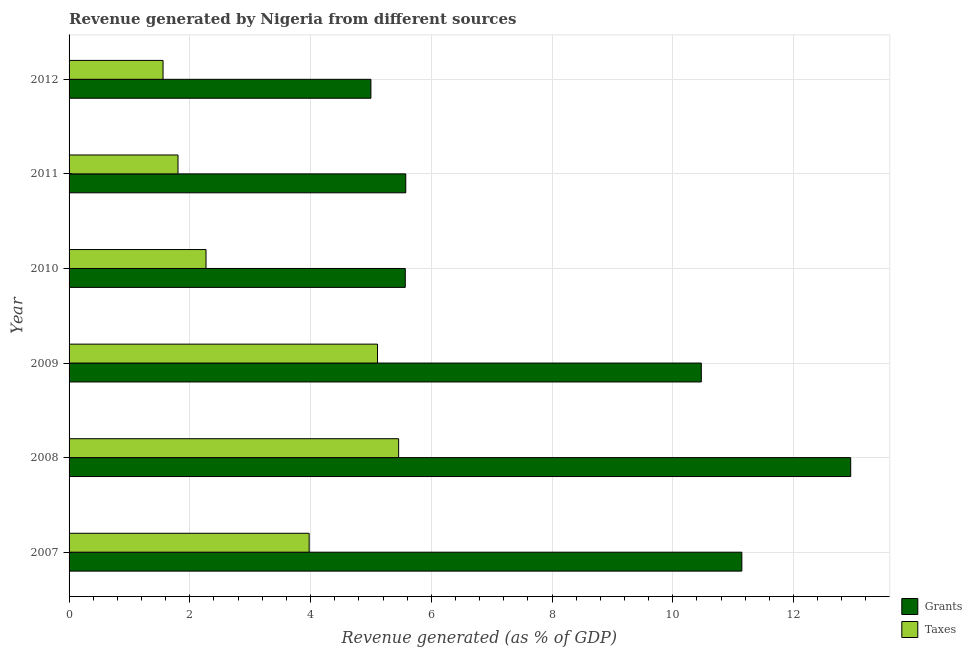How many different coloured bars are there?
Offer a very short reply. 2. Are the number of bars on each tick of the Y-axis equal?
Keep it short and to the point. Yes. How many bars are there on the 1st tick from the top?
Give a very brief answer. 2. In how many cases, is the number of bars for a given year not equal to the number of legend labels?
Provide a short and direct response. 0. What is the revenue generated by grants in 2011?
Offer a terse response. 5.58. Across all years, what is the maximum revenue generated by grants?
Provide a short and direct response. 12.95. Across all years, what is the minimum revenue generated by taxes?
Offer a terse response. 1.56. In which year was the revenue generated by taxes minimum?
Provide a short and direct response. 2012. What is the total revenue generated by grants in the graph?
Provide a short and direct response. 50.71. What is the difference between the revenue generated by grants in 2010 and that in 2011?
Give a very brief answer. -0.01. What is the difference between the revenue generated by grants in 2009 and the revenue generated by taxes in 2011?
Make the answer very short. 8.67. What is the average revenue generated by grants per year?
Keep it short and to the point. 8.45. In the year 2008, what is the difference between the revenue generated by grants and revenue generated by taxes?
Provide a short and direct response. 7.49. What is the ratio of the revenue generated by taxes in 2007 to that in 2011?
Ensure brevity in your answer.  2.2. Is the difference between the revenue generated by taxes in 2008 and 2010 greater than the difference between the revenue generated by grants in 2008 and 2010?
Offer a terse response. No. What is the difference between the highest and the second highest revenue generated by grants?
Your response must be concise. 1.8. What is the difference between the highest and the lowest revenue generated by taxes?
Ensure brevity in your answer.  3.9. In how many years, is the revenue generated by grants greater than the average revenue generated by grants taken over all years?
Give a very brief answer. 3. Is the sum of the revenue generated by taxes in 2007 and 2008 greater than the maximum revenue generated by grants across all years?
Your answer should be very brief. No. What does the 1st bar from the top in 2007 represents?
Your answer should be very brief. Taxes. What does the 2nd bar from the bottom in 2007 represents?
Make the answer very short. Taxes. How many bars are there?
Your response must be concise. 12. Are all the bars in the graph horizontal?
Give a very brief answer. Yes. How many years are there in the graph?
Ensure brevity in your answer.  6. Are the values on the major ticks of X-axis written in scientific E-notation?
Ensure brevity in your answer.  No. Does the graph contain any zero values?
Make the answer very short. No. Does the graph contain grids?
Keep it short and to the point. Yes. How are the legend labels stacked?
Provide a short and direct response. Vertical. What is the title of the graph?
Your answer should be very brief. Revenue generated by Nigeria from different sources. Does "Nitrous oxide" appear as one of the legend labels in the graph?
Offer a very short reply. No. What is the label or title of the X-axis?
Offer a terse response. Revenue generated (as % of GDP). What is the label or title of the Y-axis?
Your answer should be compact. Year. What is the Revenue generated (as % of GDP) of Grants in 2007?
Offer a terse response. 11.14. What is the Revenue generated (as % of GDP) of Taxes in 2007?
Offer a terse response. 3.98. What is the Revenue generated (as % of GDP) of Grants in 2008?
Give a very brief answer. 12.95. What is the Revenue generated (as % of GDP) of Taxes in 2008?
Your answer should be compact. 5.46. What is the Revenue generated (as % of GDP) in Grants in 2009?
Your response must be concise. 10.47. What is the Revenue generated (as % of GDP) of Taxes in 2009?
Ensure brevity in your answer.  5.11. What is the Revenue generated (as % of GDP) of Grants in 2010?
Offer a terse response. 5.57. What is the Revenue generated (as % of GDP) of Taxes in 2010?
Give a very brief answer. 2.27. What is the Revenue generated (as % of GDP) of Grants in 2011?
Your answer should be compact. 5.58. What is the Revenue generated (as % of GDP) in Taxes in 2011?
Offer a very short reply. 1.8. What is the Revenue generated (as % of GDP) in Grants in 2012?
Provide a short and direct response. 5. What is the Revenue generated (as % of GDP) of Taxes in 2012?
Offer a very short reply. 1.56. Across all years, what is the maximum Revenue generated (as % of GDP) of Grants?
Your response must be concise. 12.95. Across all years, what is the maximum Revenue generated (as % of GDP) of Taxes?
Your answer should be compact. 5.46. Across all years, what is the minimum Revenue generated (as % of GDP) in Grants?
Your answer should be compact. 5. Across all years, what is the minimum Revenue generated (as % of GDP) of Taxes?
Ensure brevity in your answer.  1.56. What is the total Revenue generated (as % of GDP) in Grants in the graph?
Ensure brevity in your answer.  50.71. What is the total Revenue generated (as % of GDP) in Taxes in the graph?
Make the answer very short. 20.17. What is the difference between the Revenue generated (as % of GDP) of Grants in 2007 and that in 2008?
Keep it short and to the point. -1.8. What is the difference between the Revenue generated (as % of GDP) of Taxes in 2007 and that in 2008?
Your answer should be very brief. -1.48. What is the difference between the Revenue generated (as % of GDP) of Grants in 2007 and that in 2009?
Offer a very short reply. 0.67. What is the difference between the Revenue generated (as % of GDP) of Taxes in 2007 and that in 2009?
Provide a short and direct response. -1.13. What is the difference between the Revenue generated (as % of GDP) of Grants in 2007 and that in 2010?
Keep it short and to the point. 5.58. What is the difference between the Revenue generated (as % of GDP) of Taxes in 2007 and that in 2010?
Your answer should be very brief. 1.71. What is the difference between the Revenue generated (as % of GDP) in Grants in 2007 and that in 2011?
Offer a very short reply. 5.57. What is the difference between the Revenue generated (as % of GDP) in Taxes in 2007 and that in 2011?
Make the answer very short. 2.17. What is the difference between the Revenue generated (as % of GDP) in Grants in 2007 and that in 2012?
Provide a succinct answer. 6.14. What is the difference between the Revenue generated (as % of GDP) of Taxes in 2007 and that in 2012?
Keep it short and to the point. 2.42. What is the difference between the Revenue generated (as % of GDP) in Grants in 2008 and that in 2009?
Ensure brevity in your answer.  2.47. What is the difference between the Revenue generated (as % of GDP) of Taxes in 2008 and that in 2009?
Keep it short and to the point. 0.35. What is the difference between the Revenue generated (as % of GDP) in Grants in 2008 and that in 2010?
Offer a very short reply. 7.38. What is the difference between the Revenue generated (as % of GDP) of Taxes in 2008 and that in 2010?
Your response must be concise. 3.19. What is the difference between the Revenue generated (as % of GDP) in Grants in 2008 and that in 2011?
Give a very brief answer. 7.37. What is the difference between the Revenue generated (as % of GDP) in Taxes in 2008 and that in 2011?
Keep it short and to the point. 3.65. What is the difference between the Revenue generated (as % of GDP) in Grants in 2008 and that in 2012?
Give a very brief answer. 7.95. What is the difference between the Revenue generated (as % of GDP) of Taxes in 2008 and that in 2012?
Provide a short and direct response. 3.9. What is the difference between the Revenue generated (as % of GDP) of Grants in 2009 and that in 2010?
Keep it short and to the point. 4.9. What is the difference between the Revenue generated (as % of GDP) in Taxes in 2009 and that in 2010?
Give a very brief answer. 2.84. What is the difference between the Revenue generated (as % of GDP) in Grants in 2009 and that in 2011?
Provide a succinct answer. 4.9. What is the difference between the Revenue generated (as % of GDP) in Taxes in 2009 and that in 2011?
Make the answer very short. 3.3. What is the difference between the Revenue generated (as % of GDP) of Grants in 2009 and that in 2012?
Offer a terse response. 5.47. What is the difference between the Revenue generated (as % of GDP) in Taxes in 2009 and that in 2012?
Keep it short and to the point. 3.55. What is the difference between the Revenue generated (as % of GDP) of Grants in 2010 and that in 2011?
Provide a succinct answer. -0.01. What is the difference between the Revenue generated (as % of GDP) in Taxes in 2010 and that in 2011?
Offer a terse response. 0.46. What is the difference between the Revenue generated (as % of GDP) of Grants in 2010 and that in 2012?
Ensure brevity in your answer.  0.57. What is the difference between the Revenue generated (as % of GDP) in Taxes in 2010 and that in 2012?
Offer a very short reply. 0.71. What is the difference between the Revenue generated (as % of GDP) of Grants in 2011 and that in 2012?
Provide a short and direct response. 0.58. What is the difference between the Revenue generated (as % of GDP) in Taxes in 2011 and that in 2012?
Provide a succinct answer. 0.25. What is the difference between the Revenue generated (as % of GDP) of Grants in 2007 and the Revenue generated (as % of GDP) of Taxes in 2008?
Provide a short and direct response. 5.69. What is the difference between the Revenue generated (as % of GDP) of Grants in 2007 and the Revenue generated (as % of GDP) of Taxes in 2009?
Give a very brief answer. 6.04. What is the difference between the Revenue generated (as % of GDP) of Grants in 2007 and the Revenue generated (as % of GDP) of Taxes in 2010?
Provide a short and direct response. 8.88. What is the difference between the Revenue generated (as % of GDP) of Grants in 2007 and the Revenue generated (as % of GDP) of Taxes in 2011?
Offer a terse response. 9.34. What is the difference between the Revenue generated (as % of GDP) of Grants in 2007 and the Revenue generated (as % of GDP) of Taxes in 2012?
Provide a succinct answer. 9.59. What is the difference between the Revenue generated (as % of GDP) in Grants in 2008 and the Revenue generated (as % of GDP) in Taxes in 2009?
Offer a terse response. 7.84. What is the difference between the Revenue generated (as % of GDP) in Grants in 2008 and the Revenue generated (as % of GDP) in Taxes in 2010?
Keep it short and to the point. 10.68. What is the difference between the Revenue generated (as % of GDP) in Grants in 2008 and the Revenue generated (as % of GDP) in Taxes in 2011?
Offer a terse response. 11.14. What is the difference between the Revenue generated (as % of GDP) in Grants in 2008 and the Revenue generated (as % of GDP) in Taxes in 2012?
Provide a short and direct response. 11.39. What is the difference between the Revenue generated (as % of GDP) in Grants in 2009 and the Revenue generated (as % of GDP) in Taxes in 2010?
Your answer should be compact. 8.2. What is the difference between the Revenue generated (as % of GDP) in Grants in 2009 and the Revenue generated (as % of GDP) in Taxes in 2011?
Provide a short and direct response. 8.67. What is the difference between the Revenue generated (as % of GDP) in Grants in 2009 and the Revenue generated (as % of GDP) in Taxes in 2012?
Offer a terse response. 8.92. What is the difference between the Revenue generated (as % of GDP) of Grants in 2010 and the Revenue generated (as % of GDP) of Taxes in 2011?
Offer a terse response. 3.76. What is the difference between the Revenue generated (as % of GDP) of Grants in 2010 and the Revenue generated (as % of GDP) of Taxes in 2012?
Give a very brief answer. 4.01. What is the difference between the Revenue generated (as % of GDP) in Grants in 2011 and the Revenue generated (as % of GDP) in Taxes in 2012?
Provide a succinct answer. 4.02. What is the average Revenue generated (as % of GDP) in Grants per year?
Keep it short and to the point. 8.45. What is the average Revenue generated (as % of GDP) in Taxes per year?
Make the answer very short. 3.36. In the year 2007, what is the difference between the Revenue generated (as % of GDP) in Grants and Revenue generated (as % of GDP) in Taxes?
Keep it short and to the point. 7.17. In the year 2008, what is the difference between the Revenue generated (as % of GDP) in Grants and Revenue generated (as % of GDP) in Taxes?
Your answer should be compact. 7.49. In the year 2009, what is the difference between the Revenue generated (as % of GDP) of Grants and Revenue generated (as % of GDP) of Taxes?
Ensure brevity in your answer.  5.36. In the year 2010, what is the difference between the Revenue generated (as % of GDP) of Grants and Revenue generated (as % of GDP) of Taxes?
Offer a very short reply. 3.3. In the year 2011, what is the difference between the Revenue generated (as % of GDP) in Grants and Revenue generated (as % of GDP) in Taxes?
Ensure brevity in your answer.  3.77. In the year 2012, what is the difference between the Revenue generated (as % of GDP) in Grants and Revenue generated (as % of GDP) in Taxes?
Keep it short and to the point. 3.44. What is the ratio of the Revenue generated (as % of GDP) of Grants in 2007 to that in 2008?
Keep it short and to the point. 0.86. What is the ratio of the Revenue generated (as % of GDP) in Taxes in 2007 to that in 2008?
Your answer should be very brief. 0.73. What is the ratio of the Revenue generated (as % of GDP) in Grants in 2007 to that in 2009?
Offer a terse response. 1.06. What is the ratio of the Revenue generated (as % of GDP) in Taxes in 2007 to that in 2009?
Your answer should be compact. 0.78. What is the ratio of the Revenue generated (as % of GDP) in Grants in 2007 to that in 2010?
Keep it short and to the point. 2. What is the ratio of the Revenue generated (as % of GDP) in Taxes in 2007 to that in 2010?
Ensure brevity in your answer.  1.75. What is the ratio of the Revenue generated (as % of GDP) in Grants in 2007 to that in 2011?
Keep it short and to the point. 2. What is the ratio of the Revenue generated (as % of GDP) of Taxes in 2007 to that in 2011?
Your response must be concise. 2.2. What is the ratio of the Revenue generated (as % of GDP) in Grants in 2007 to that in 2012?
Provide a short and direct response. 2.23. What is the ratio of the Revenue generated (as % of GDP) of Taxes in 2007 to that in 2012?
Make the answer very short. 2.55. What is the ratio of the Revenue generated (as % of GDP) in Grants in 2008 to that in 2009?
Ensure brevity in your answer.  1.24. What is the ratio of the Revenue generated (as % of GDP) of Taxes in 2008 to that in 2009?
Keep it short and to the point. 1.07. What is the ratio of the Revenue generated (as % of GDP) in Grants in 2008 to that in 2010?
Offer a very short reply. 2.32. What is the ratio of the Revenue generated (as % of GDP) in Taxes in 2008 to that in 2010?
Offer a very short reply. 2.41. What is the ratio of the Revenue generated (as % of GDP) of Grants in 2008 to that in 2011?
Make the answer very short. 2.32. What is the ratio of the Revenue generated (as % of GDP) in Taxes in 2008 to that in 2011?
Offer a terse response. 3.03. What is the ratio of the Revenue generated (as % of GDP) in Grants in 2008 to that in 2012?
Your answer should be compact. 2.59. What is the ratio of the Revenue generated (as % of GDP) in Taxes in 2008 to that in 2012?
Make the answer very short. 3.51. What is the ratio of the Revenue generated (as % of GDP) in Grants in 2009 to that in 2010?
Your answer should be compact. 1.88. What is the ratio of the Revenue generated (as % of GDP) of Taxes in 2009 to that in 2010?
Offer a terse response. 2.25. What is the ratio of the Revenue generated (as % of GDP) in Grants in 2009 to that in 2011?
Make the answer very short. 1.88. What is the ratio of the Revenue generated (as % of GDP) of Taxes in 2009 to that in 2011?
Keep it short and to the point. 2.83. What is the ratio of the Revenue generated (as % of GDP) of Grants in 2009 to that in 2012?
Provide a short and direct response. 2.09. What is the ratio of the Revenue generated (as % of GDP) of Taxes in 2009 to that in 2012?
Provide a succinct answer. 3.28. What is the ratio of the Revenue generated (as % of GDP) in Grants in 2010 to that in 2011?
Provide a succinct answer. 1. What is the ratio of the Revenue generated (as % of GDP) in Taxes in 2010 to that in 2011?
Give a very brief answer. 1.26. What is the ratio of the Revenue generated (as % of GDP) of Grants in 2010 to that in 2012?
Offer a very short reply. 1.11. What is the ratio of the Revenue generated (as % of GDP) of Taxes in 2010 to that in 2012?
Keep it short and to the point. 1.46. What is the ratio of the Revenue generated (as % of GDP) in Grants in 2011 to that in 2012?
Provide a succinct answer. 1.12. What is the ratio of the Revenue generated (as % of GDP) in Taxes in 2011 to that in 2012?
Keep it short and to the point. 1.16. What is the difference between the highest and the second highest Revenue generated (as % of GDP) of Grants?
Offer a very short reply. 1.8. What is the difference between the highest and the second highest Revenue generated (as % of GDP) of Taxes?
Provide a short and direct response. 0.35. What is the difference between the highest and the lowest Revenue generated (as % of GDP) of Grants?
Your answer should be compact. 7.95. What is the difference between the highest and the lowest Revenue generated (as % of GDP) of Taxes?
Provide a short and direct response. 3.9. 